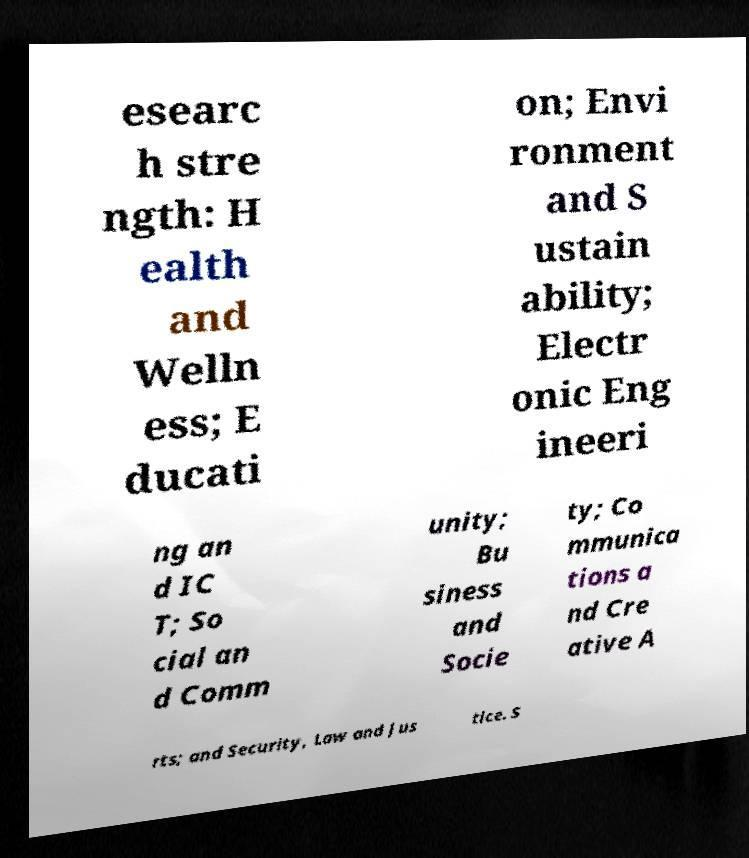Can you read and provide the text displayed in the image?This photo seems to have some interesting text. Can you extract and type it out for me? esearc h stre ngth: H ealth and Welln ess; E ducati on; Envi ronment and S ustain ability; Electr onic Eng ineeri ng an d IC T; So cial an d Comm unity; Bu siness and Socie ty; Co mmunica tions a nd Cre ative A rts; and Security, Law and Jus tice. S 